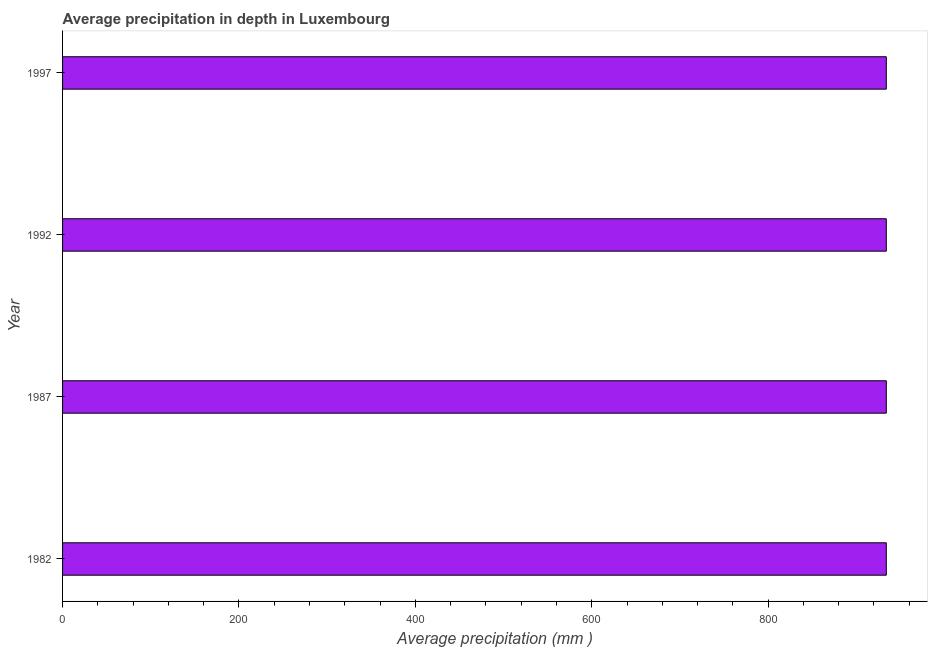Does the graph contain grids?
Provide a short and direct response. No. What is the title of the graph?
Offer a very short reply. Average precipitation in depth in Luxembourg. What is the label or title of the X-axis?
Your answer should be very brief. Average precipitation (mm ). What is the label or title of the Y-axis?
Offer a terse response. Year. What is the average precipitation in depth in 1992?
Your answer should be compact. 934. Across all years, what is the maximum average precipitation in depth?
Your answer should be very brief. 934. Across all years, what is the minimum average precipitation in depth?
Your answer should be compact. 934. What is the sum of the average precipitation in depth?
Your response must be concise. 3736. What is the difference between the average precipitation in depth in 1987 and 1997?
Make the answer very short. 0. What is the average average precipitation in depth per year?
Provide a short and direct response. 934. What is the median average precipitation in depth?
Provide a succinct answer. 934. What is the ratio of the average precipitation in depth in 1992 to that in 1997?
Offer a very short reply. 1. What is the difference between the highest and the lowest average precipitation in depth?
Your response must be concise. 0. How many bars are there?
Give a very brief answer. 4. Are all the bars in the graph horizontal?
Provide a succinct answer. Yes. What is the Average precipitation (mm ) of 1982?
Your response must be concise. 934. What is the Average precipitation (mm ) in 1987?
Offer a very short reply. 934. What is the Average precipitation (mm ) of 1992?
Your response must be concise. 934. What is the Average precipitation (mm ) of 1997?
Offer a very short reply. 934. What is the difference between the Average precipitation (mm ) in 1982 and 1992?
Provide a succinct answer. 0. What is the difference between the Average precipitation (mm ) in 1982 and 1997?
Your answer should be compact. 0. What is the ratio of the Average precipitation (mm ) in 1982 to that in 1997?
Provide a succinct answer. 1. What is the ratio of the Average precipitation (mm ) in 1987 to that in 1992?
Offer a terse response. 1. What is the ratio of the Average precipitation (mm ) in 1987 to that in 1997?
Your answer should be compact. 1. 